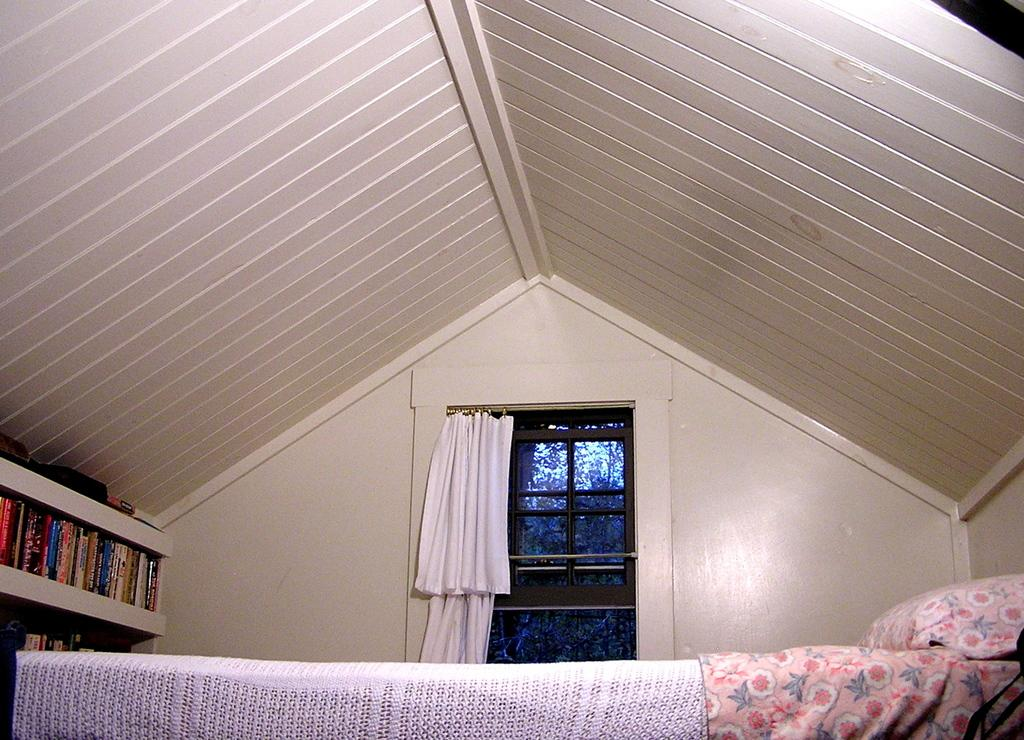What piece of furniture is present in the image? There is a bed in the image. What is placed on the bed? There is a pillow on the bed. What type of window is visible in the image? There is a glass window with a curtain in the image. Where are the books located in the image? The books are on a rack on the left side of the image. What type of roof is present in the image? There is a wooden roof in the image. Can you see a goose walking on the wooden roof in the image? There is no goose or any indication of a goose walking on the wooden roof in the image. 